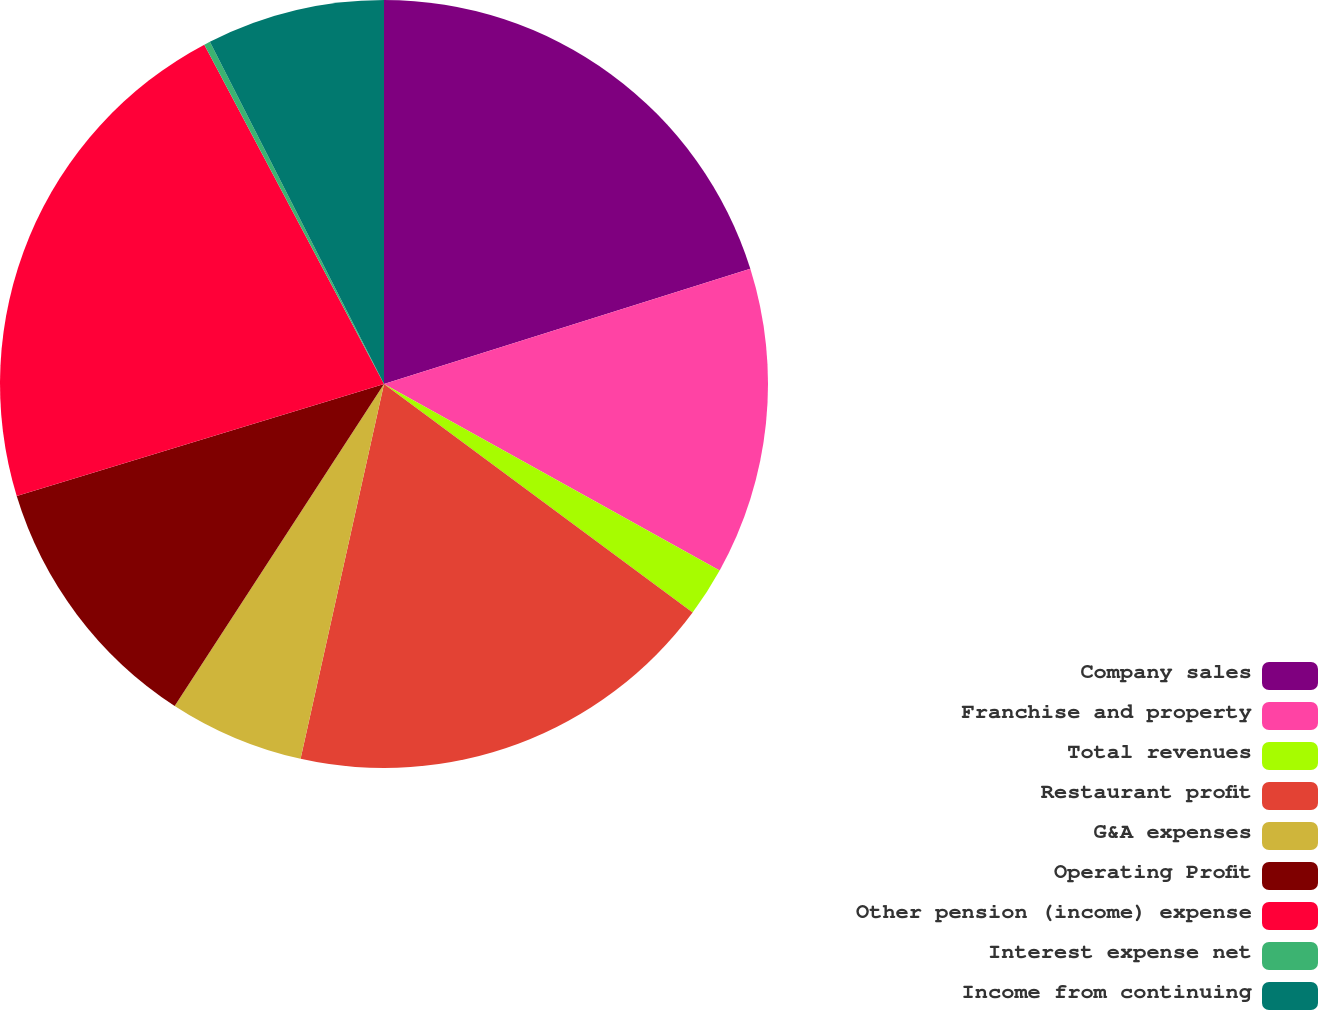<chart> <loc_0><loc_0><loc_500><loc_500><pie_chart><fcel>Company sales<fcel>Franchise and property<fcel>Total revenues<fcel>Restaurant profit<fcel>G&A expenses<fcel>Operating Profit<fcel>Other pension (income) expense<fcel>Interest expense net<fcel>Income from continuing<nl><fcel>20.15%<fcel>12.92%<fcel>2.07%<fcel>18.34%<fcel>5.69%<fcel>11.11%<fcel>21.96%<fcel>0.26%<fcel>7.49%<nl></chart> 